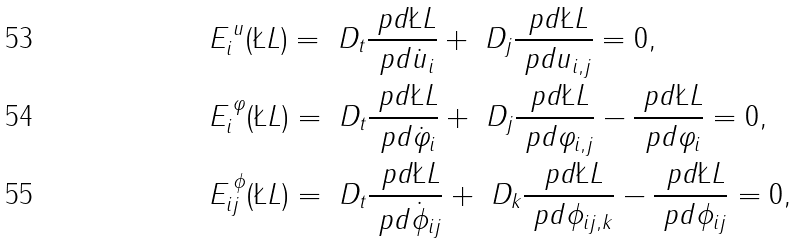Convert formula to latex. <formula><loc_0><loc_0><loc_500><loc_500>& E ^ { \, u } _ { i } ( \L L ) = \ D _ { t } \frac { \ p d \L L } { \ p d \dot { u } _ { i } } + \ D _ { j } \frac { \ p d \L L } { \ p d u _ { i , j } } = 0 , \\ & E ^ { \, \varphi } _ { i } ( \L L ) = \ D _ { t } \frac { \ p d \L L } { \ p d \dot { \varphi } _ { i } } + \ D _ { j } \frac { \ p d \L L } { \ p d \varphi _ { i , j } } - \frac { \ p d \L L } { \ p d \varphi _ { i } } = 0 , \\ & E ^ { \, \phi } _ { i j } ( \L L ) = \ D _ { t } \frac { \ p d \L L } { \ p d \dot { \phi } _ { i j } } + \ D _ { k } \frac { \ p d \L L } { \ p d \phi _ { i j , k } } - \frac { \ p d \L L } { \ p d \phi _ { i j } } = 0 ,</formula> 